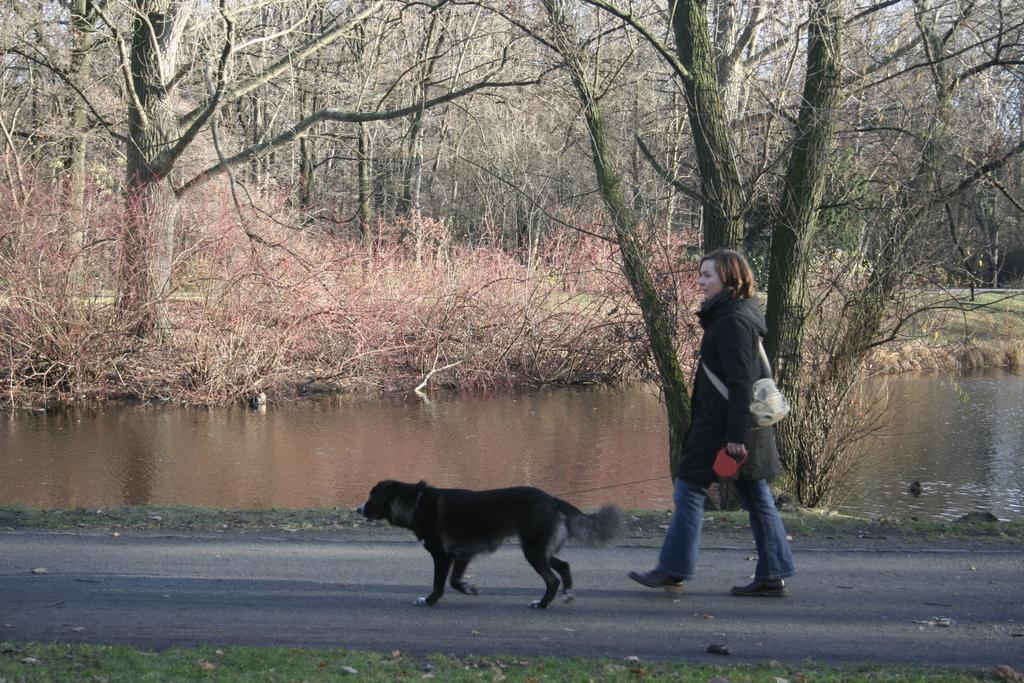Who is present in the image? There is a woman in the image. What is the woman doing in the image? The woman is walking with a dog in the image. Where are they walking? They are on a road in the image. What can be seen in the background of the image? There is a pond in the background of the image, and there are trees near the pond. To create the conversation, we first identify the main subject, which is the woman. Then, we describe her actions and the setting in which she is walking. Finally, we mention the background elements, such as the pond and trees. Each question is designed to elicit a specific detail about the image that is known from the provided facts. Absurd Question/Answer: What color is the dog's attention in the image? The dog's attention is not a color; it refers to the dog's focus or awareness. Additionally, there is no mention of the dog's attention in the image. What type of silver object is visible in the image? There is no silver object present in the image. 